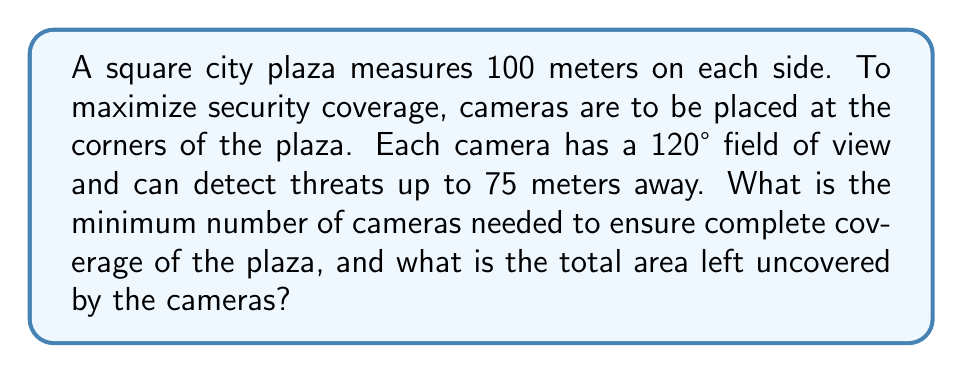Help me with this question. Let's approach this step-by-step:

1) First, we need to determine the coverage area of each camera. The cameras are positioned at the corners of the square plaza, creating a circular sector of coverage.

2) The area of a circular sector is given by the formula:
   $$A = \frac{1}{2}r^2\theta$$
   where $r$ is the radius and $\theta$ is the angle in radians.

3) We're given that $r = 75$ meters and the angle is 120°. We need to convert 120° to radians:
   $$120° \times \frac{\pi}{180°} = \frac{2\pi}{3} \text{ radians}$$

4) Now we can calculate the area of each camera's coverage:
   $$A = \frac{1}{2} \times 75^2 \times \frac{2\pi}{3} = 5890.49 \text{ m}^2$$

5) The total area of the square plaza is:
   $$100 \text{ m} \times 100 \text{ m} = 10,000 \text{ m}^2$$

6) To determine the minimum number of cameras, we need to consider the geometry of the square. Four cameras, one at each corner, will provide complete coverage with some overlap.

7) To calculate the uncovered area, we need to subtract the coverage of four cameras from the total area of the square, and then add back the areas of overlap (which we've subtracted twice).

8) The overlap occurs in the corners of the square. Each overlap is a triangle with base and height equal to $(75 - \frac{100}{\sqrt{2}})$. The area of each overlap triangle is:
   $$A_{\text{overlap}} = \frac{1}{2} \times (75 - \frac{100}{\sqrt{2}})^2 = 240.49 \text{ m}^2$$

9) Total uncovered area:
   $$10,000 - (4 \times 5890.49) + (4 \times 240.49) = 1961.96 \text{ m}^2$$

[asy]
unitsize(0.05);
draw((-50,-50)--(50,-50)--(50,50)--(-50,50)--cycle);
draw(arc((-50,-50),75,0,120));
draw(arc((50,-50),75,60,180));
draw(arc((50,50),75,180,300));
draw(arc((-50,50),75,240,360));
label("100m", (0,-55));
label("100m", (55,0), E);
[/asy]
Answer: 4 cameras; 1961.96 m² 